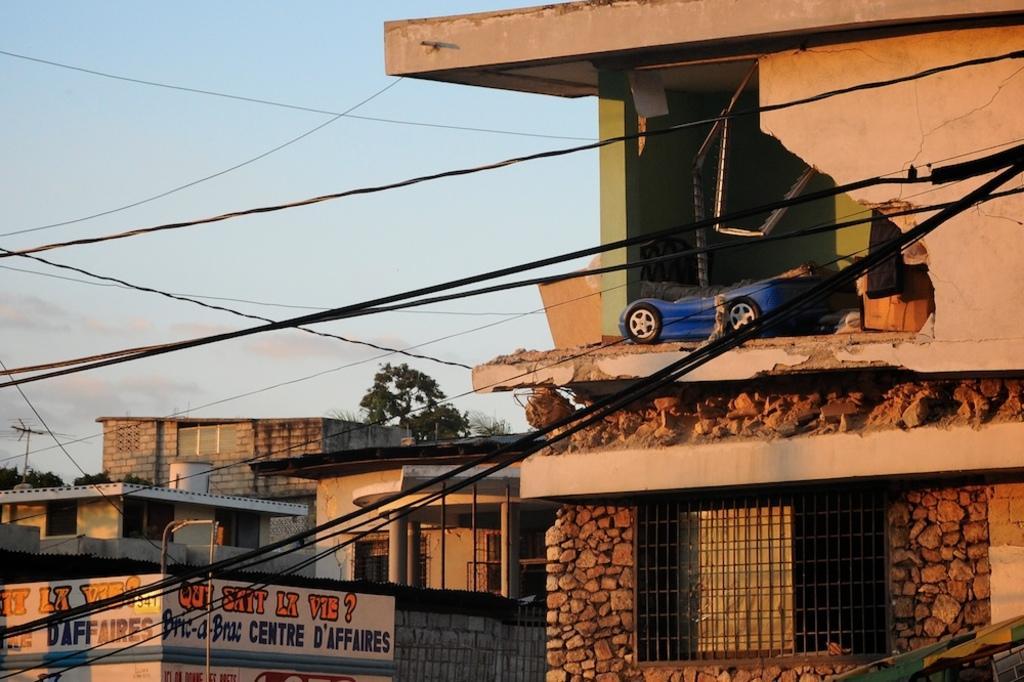In one or two sentences, can you explain what this image depicts? In this image we can see the crumbled wall. And we can see a toy car. And we can see the buildings. And we can see the cables, windows. And we can see the trees and the sky. 